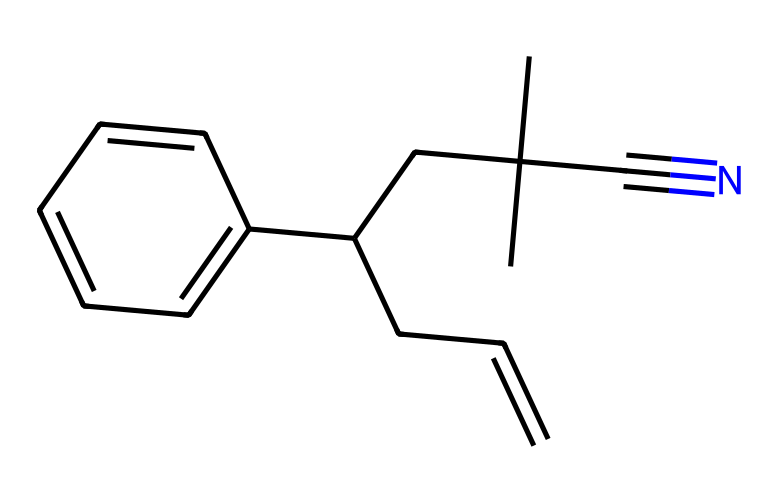What is the main functional group present in this chemical? The structure contains a cyano group (-C≡N), identified by the presence of a carbon triple-bonded to a nitrogen atom, which is a characteristic functional group in acrylonitrile.
Answer: cyano How many carbon atoms are in this molecule? By counting the carbon atoms in the SMILES representation, you can identify that there are 12 carbon atoms present in the structure.
Answer: 12 What type of polymer is acrylonitrile butadiene styrene (ABS)? ABS is a thermoplastic polymer, which is characterized by its ability to be softened by heat and hardened by cooling.
Answer: thermoplastic What is the significance of the butadiene component in this polymer? The butadiene component contributes to the rubber-like properties of the polymer, enhancing its impact resistance and flexibility compared to other plastics.
Answer: impact resistance How many nitrogen atoms are present in the molecule? The SMILES representation shows a single nitrogen atom indicated by the cyano group; thus, there is only one nitrogen atom in the entire structure.
Answer: 1 What aspect of ABS makes it suitable for keyboard manufacturing? The thermal stability and durability of ABS enable it to withstand ongoing mechanical stress and offer a smooth surface for key presses, making it ideal for keyboard construction.
Answer: thermal stability 